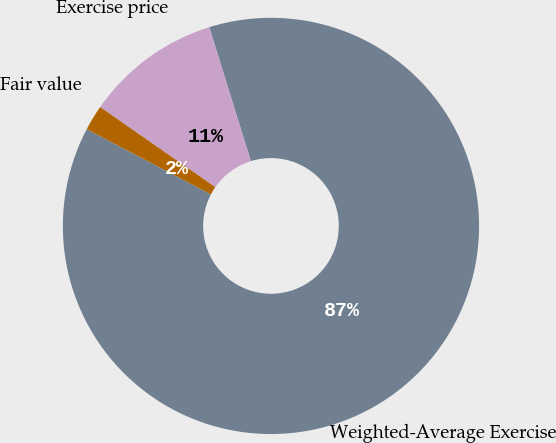Convert chart. <chart><loc_0><loc_0><loc_500><loc_500><pie_chart><fcel>Weighted-Average Exercise<fcel>Exercise price<fcel>Fair value<nl><fcel>87.48%<fcel>10.53%<fcel>1.98%<nl></chart> 